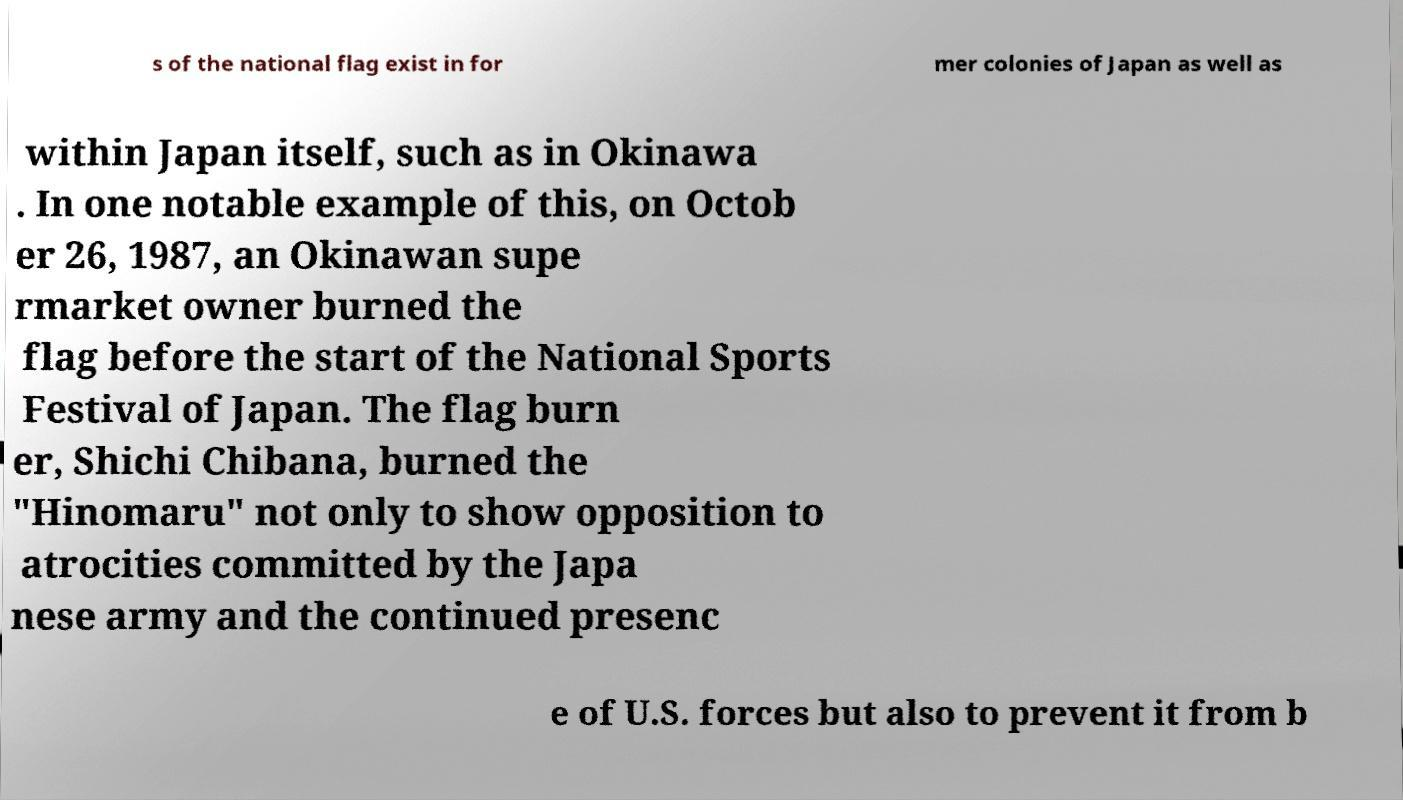Can you read and provide the text displayed in the image?This photo seems to have some interesting text. Can you extract and type it out for me? s of the national flag exist in for mer colonies of Japan as well as within Japan itself, such as in Okinawa . In one notable example of this, on Octob er 26, 1987, an Okinawan supe rmarket owner burned the flag before the start of the National Sports Festival of Japan. The flag burn er, Shichi Chibana, burned the "Hinomaru" not only to show opposition to atrocities committed by the Japa nese army and the continued presenc e of U.S. forces but also to prevent it from b 